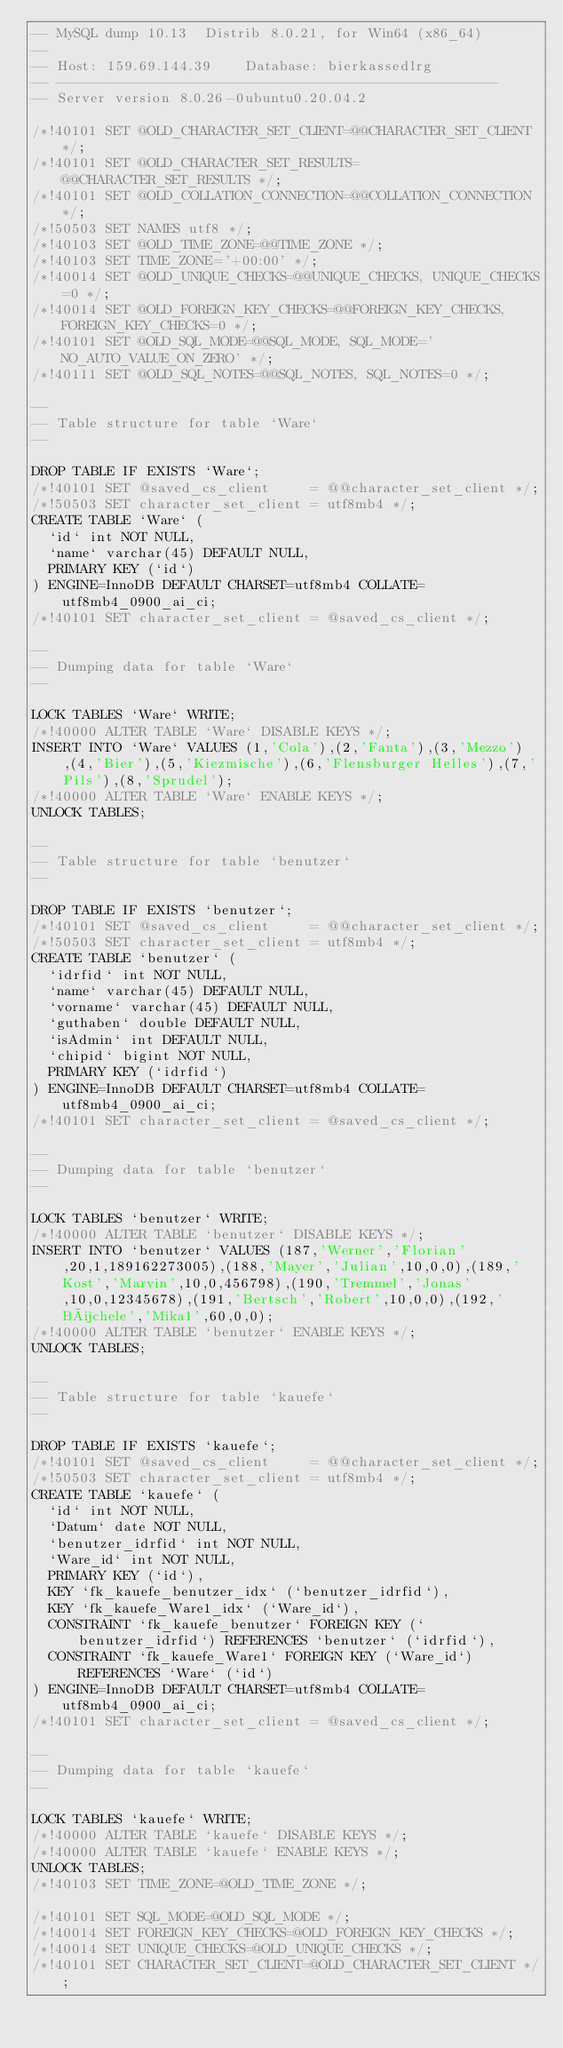<code> <loc_0><loc_0><loc_500><loc_500><_SQL_>-- MySQL dump 10.13  Distrib 8.0.21, for Win64 (x86_64)
--
-- Host: 159.69.144.39    Database: bierkassedlrg
-- ------------------------------------------------------
-- Server version	8.0.26-0ubuntu0.20.04.2

/*!40101 SET @OLD_CHARACTER_SET_CLIENT=@@CHARACTER_SET_CLIENT */;
/*!40101 SET @OLD_CHARACTER_SET_RESULTS=@@CHARACTER_SET_RESULTS */;
/*!40101 SET @OLD_COLLATION_CONNECTION=@@COLLATION_CONNECTION */;
/*!50503 SET NAMES utf8 */;
/*!40103 SET @OLD_TIME_ZONE=@@TIME_ZONE */;
/*!40103 SET TIME_ZONE='+00:00' */;
/*!40014 SET @OLD_UNIQUE_CHECKS=@@UNIQUE_CHECKS, UNIQUE_CHECKS=0 */;
/*!40014 SET @OLD_FOREIGN_KEY_CHECKS=@@FOREIGN_KEY_CHECKS, FOREIGN_KEY_CHECKS=0 */;
/*!40101 SET @OLD_SQL_MODE=@@SQL_MODE, SQL_MODE='NO_AUTO_VALUE_ON_ZERO' */;
/*!40111 SET @OLD_SQL_NOTES=@@SQL_NOTES, SQL_NOTES=0 */;

--
-- Table structure for table `Ware`
--

DROP TABLE IF EXISTS `Ware`;
/*!40101 SET @saved_cs_client     = @@character_set_client */;
/*!50503 SET character_set_client = utf8mb4 */;
CREATE TABLE `Ware` (
  `id` int NOT NULL,
  `name` varchar(45) DEFAULT NULL,
  PRIMARY KEY (`id`)
) ENGINE=InnoDB DEFAULT CHARSET=utf8mb4 COLLATE=utf8mb4_0900_ai_ci;
/*!40101 SET character_set_client = @saved_cs_client */;

--
-- Dumping data for table `Ware`
--

LOCK TABLES `Ware` WRITE;
/*!40000 ALTER TABLE `Ware` DISABLE KEYS */;
INSERT INTO `Ware` VALUES (1,'Cola'),(2,'Fanta'),(3,'Mezzo'),(4,'Bier'),(5,'Kiezmische'),(6,'Flensburger Helles'),(7,'Pils'),(8,'Sprudel');
/*!40000 ALTER TABLE `Ware` ENABLE KEYS */;
UNLOCK TABLES;

--
-- Table structure for table `benutzer`
--

DROP TABLE IF EXISTS `benutzer`;
/*!40101 SET @saved_cs_client     = @@character_set_client */;
/*!50503 SET character_set_client = utf8mb4 */;
CREATE TABLE `benutzer` (
  `idrfid` int NOT NULL,
  `name` varchar(45) DEFAULT NULL,
  `vorname` varchar(45) DEFAULT NULL,
  `guthaben` double DEFAULT NULL,
  `isAdmin` int DEFAULT NULL,
  `chipid` bigint NOT NULL,
  PRIMARY KEY (`idrfid`)
) ENGINE=InnoDB DEFAULT CHARSET=utf8mb4 COLLATE=utf8mb4_0900_ai_ci;
/*!40101 SET character_set_client = @saved_cs_client */;

--
-- Dumping data for table `benutzer`
--

LOCK TABLES `benutzer` WRITE;
/*!40000 ALTER TABLE `benutzer` DISABLE KEYS */;
INSERT INTO `benutzer` VALUES (187,'Werner','Florian',20,1,189162273005),(188,'Mayer','Julian',10,0,0),(189,'Kost','Marvin',10,0,456798),(190,'Tremmel','Jonas',10,0,12345678),(191,'Bertsch','Robert',10,0,0),(192,'Büchele','Mika1',60,0,0);
/*!40000 ALTER TABLE `benutzer` ENABLE KEYS */;
UNLOCK TABLES;

--
-- Table structure for table `kauefe`
--

DROP TABLE IF EXISTS `kauefe`;
/*!40101 SET @saved_cs_client     = @@character_set_client */;
/*!50503 SET character_set_client = utf8mb4 */;
CREATE TABLE `kauefe` (
  `id` int NOT NULL,
  `Datum` date NOT NULL,
  `benutzer_idrfid` int NOT NULL,
  `Ware_id` int NOT NULL,
  PRIMARY KEY (`id`),
  KEY `fk_kauefe_benutzer_idx` (`benutzer_idrfid`),
  KEY `fk_kauefe_Ware1_idx` (`Ware_id`),
  CONSTRAINT `fk_kauefe_benutzer` FOREIGN KEY (`benutzer_idrfid`) REFERENCES `benutzer` (`idrfid`),
  CONSTRAINT `fk_kauefe_Ware1` FOREIGN KEY (`Ware_id`) REFERENCES `Ware` (`id`)
) ENGINE=InnoDB DEFAULT CHARSET=utf8mb4 COLLATE=utf8mb4_0900_ai_ci;
/*!40101 SET character_set_client = @saved_cs_client */;

--
-- Dumping data for table `kauefe`
--

LOCK TABLES `kauefe` WRITE;
/*!40000 ALTER TABLE `kauefe` DISABLE KEYS */;
/*!40000 ALTER TABLE `kauefe` ENABLE KEYS */;
UNLOCK TABLES;
/*!40103 SET TIME_ZONE=@OLD_TIME_ZONE */;

/*!40101 SET SQL_MODE=@OLD_SQL_MODE */;
/*!40014 SET FOREIGN_KEY_CHECKS=@OLD_FOREIGN_KEY_CHECKS */;
/*!40014 SET UNIQUE_CHECKS=@OLD_UNIQUE_CHECKS */;
/*!40101 SET CHARACTER_SET_CLIENT=@OLD_CHARACTER_SET_CLIENT */;</code> 